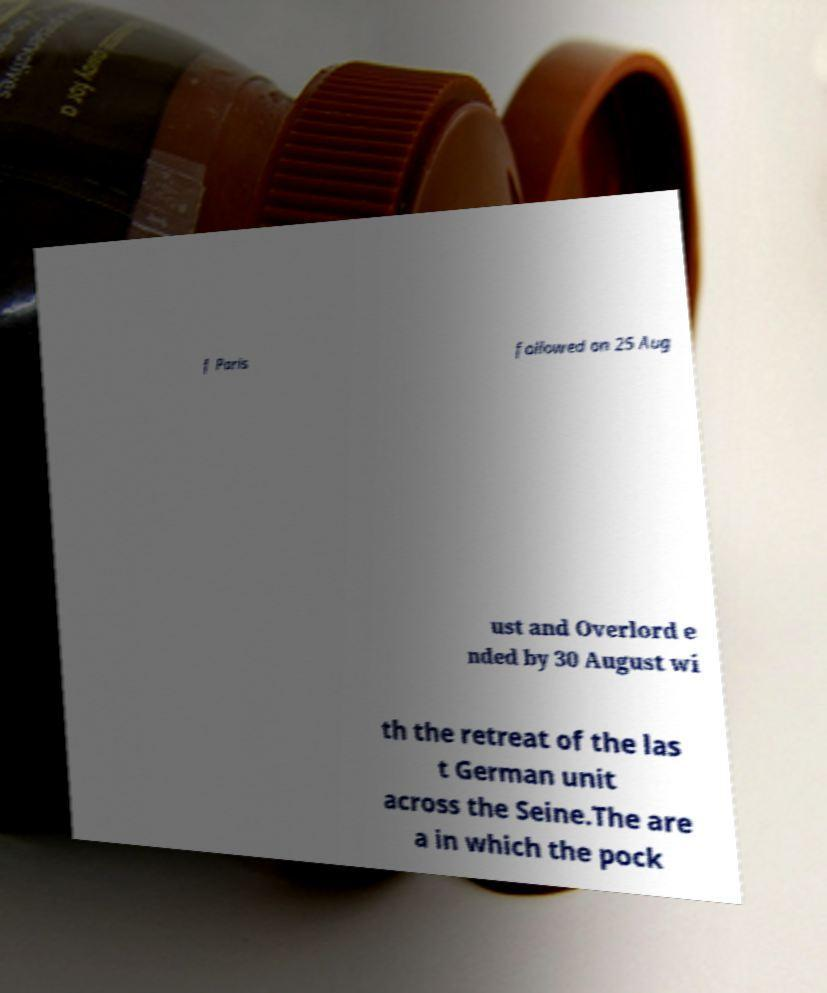For documentation purposes, I need the text within this image transcribed. Could you provide that? f Paris followed on 25 Aug ust and Overlord e nded by 30 August wi th the retreat of the las t German unit across the Seine.The are a in which the pock 